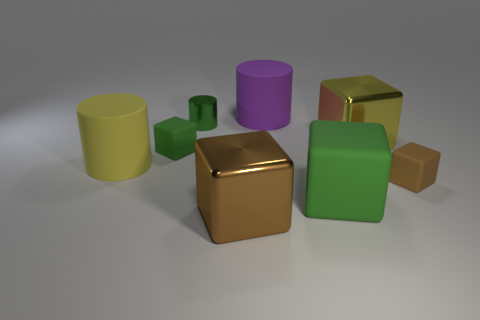Can you tell me which objects are reflecting light as if they are metallic? The golden cube appears to have a smooth and reflective surface which suggests a metallic material. Its reflections are sharp and clear, characteristic of metals. 